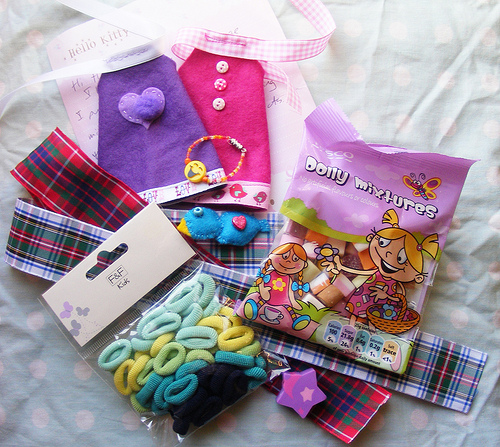<image>
Can you confirm if the candy is on the ribbon? Yes. Looking at the image, I can see the candy is positioned on top of the ribbon, with the ribbon providing support. 